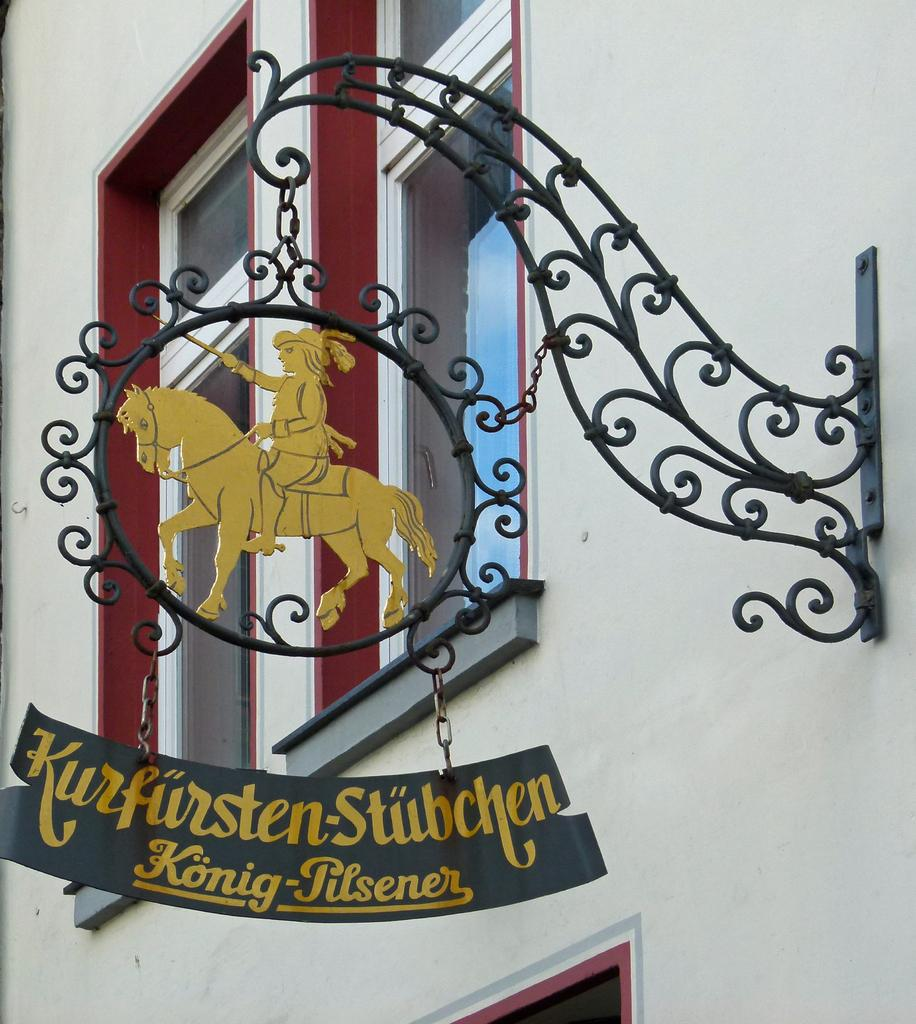What is the main object in the image? There is a name board in the image. How is the name board positioned in the image? The name board is hanging on an iron grill. Is the iron grill connected to any structure? Yes, the iron grill is attached to a building. What type of gold vase can be seen on the north side of the building in the image? There is no gold vase present in the image, nor is there any indication of the north side of the building. 